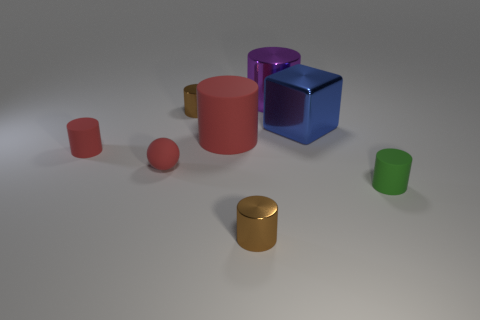Subtract all purple cylinders. How many cylinders are left? 5 Subtract all large red cylinders. How many cylinders are left? 5 Subtract all cyan cubes. Subtract all green balls. How many cubes are left? 1 Add 1 red rubber cylinders. How many objects exist? 9 Subtract all cubes. How many objects are left? 7 Add 5 tiny green cylinders. How many tiny green cylinders exist? 6 Subtract 0 blue cylinders. How many objects are left? 8 Subtract all brown cylinders. Subtract all small cylinders. How many objects are left? 2 Add 5 red objects. How many red objects are left? 8 